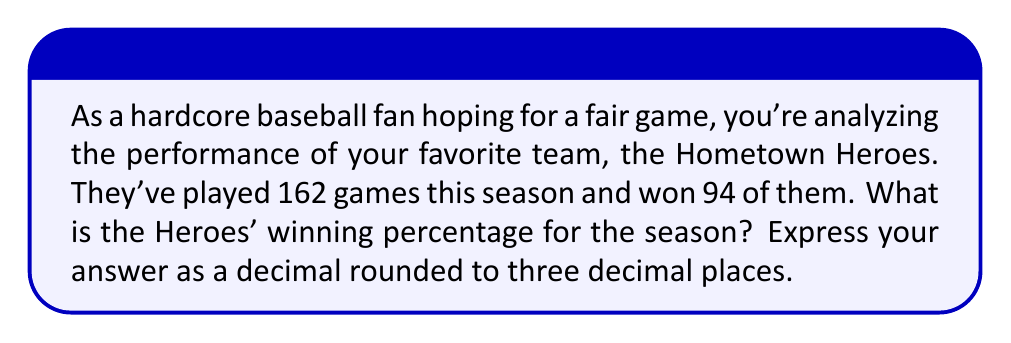Provide a solution to this math problem. To find the winning percentage of a baseball team, we need to divide the number of wins by the total number of games played. Let's break this down step-by-step:

1. Identify the given information:
   - Total games played: 162
   - Games won: 94

2. Set up the formula for winning percentage:
   $$ \text{Winning Percentage} = \frac{\text{Number of Wins}}{\text{Total Games Played}} $$

3. Plug in the values:
   $$ \text{Winning Percentage} = \frac{94}{162} $$

4. Perform the division:
   $$ \frac{94}{162} \approx 0.5802469135802469 $$

5. Round to three decimal places:
   $$ 0.5802469135802469 \approx 0.580 $$

Therefore, the Hometown Heroes' winning percentage for the season is 0.580 or 58.0%.
Answer: 0.580 